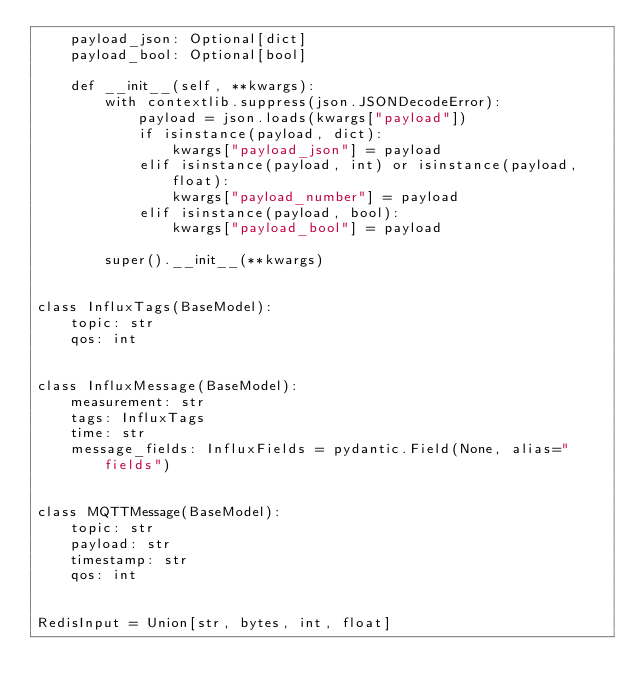Convert code to text. <code><loc_0><loc_0><loc_500><loc_500><_Python_>    payload_json: Optional[dict]
    payload_bool: Optional[bool]

    def __init__(self, **kwargs):
        with contextlib.suppress(json.JSONDecodeError):
            payload = json.loads(kwargs["payload"])
            if isinstance(payload, dict):
                kwargs["payload_json"] = payload
            elif isinstance(payload, int) or isinstance(payload, float):
                kwargs["payload_number"] = payload
            elif isinstance(payload, bool):
                kwargs["payload_bool"] = payload

        super().__init__(**kwargs)


class InfluxTags(BaseModel):
    topic: str
    qos: int


class InfluxMessage(BaseModel):
    measurement: str
    tags: InfluxTags
    time: str
    message_fields: InfluxFields = pydantic.Field(None, alias="fields")


class MQTTMessage(BaseModel):
    topic: str
    payload: str
    timestamp: str
    qos: int


RedisInput = Union[str, bytes, int, float]
</code> 